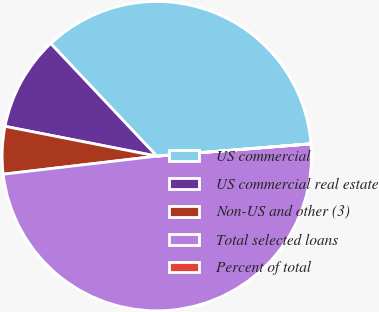Convert chart. <chart><loc_0><loc_0><loc_500><loc_500><pie_chart><fcel>US commercial<fcel>US commercial real estate<fcel>Non-US and other (3)<fcel>Total selected loans<fcel>Percent of total<nl><fcel>35.75%<fcel>9.89%<fcel>4.95%<fcel>49.4%<fcel>0.01%<nl></chart> 